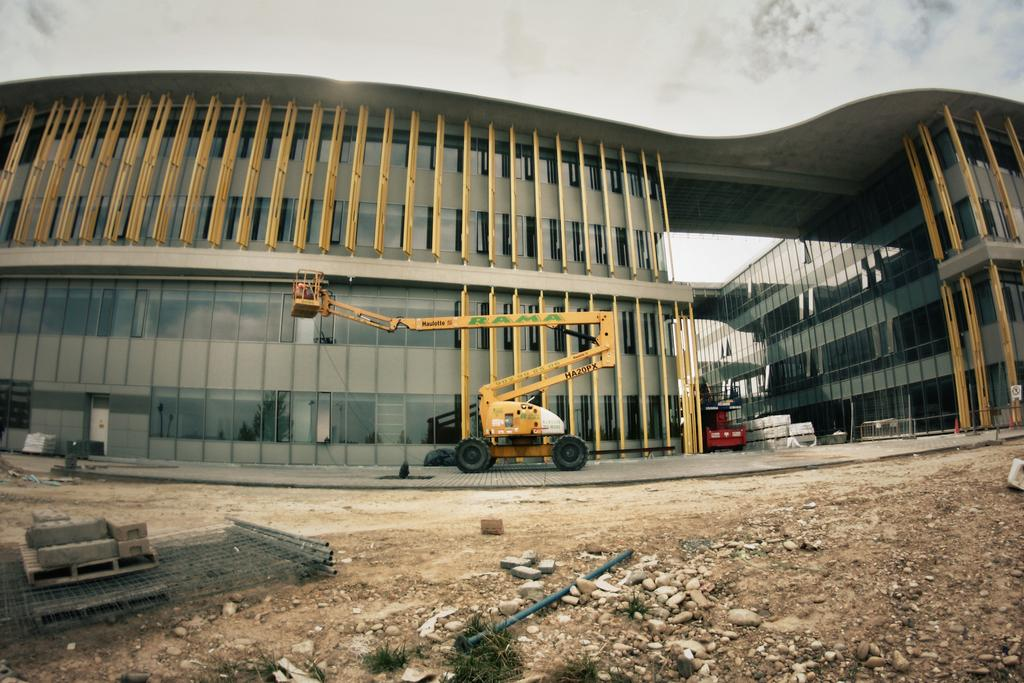What type of surface can be seen in the image? There is ground visible in the image. What object is present in the image that could be used for various purposes? There is a stick in the image. What type of natural material is present in the image? There are stones in the image. What man-made structures can be seen in the image? There is a building in the image. What type of transportation is visible in the image? There are vehicles in the image. What part of the natural environment is visible in the background of the image? The sky is visible in the background of the image, and there are clouds in the sky. What type of plantation can be seen in the image? There is no plantation present in the image. What type of pest is visible in the image? There are no pests visible in the image. 